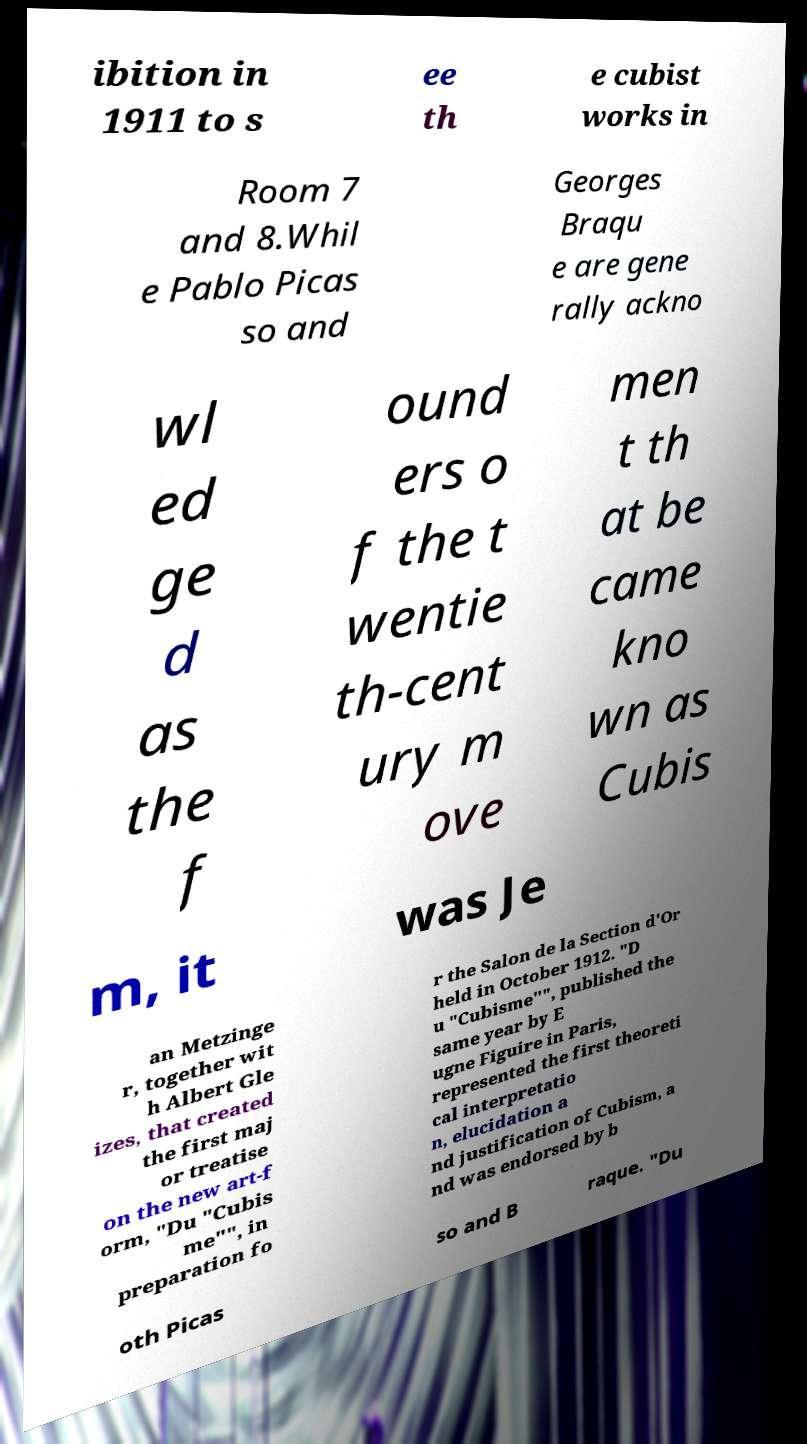I need the written content from this picture converted into text. Can you do that? ibition in 1911 to s ee th e cubist works in Room 7 and 8.Whil e Pablo Picas so and Georges Braqu e are gene rally ackno wl ed ge d as the f ound ers o f the t wentie th-cent ury m ove men t th at be came kno wn as Cubis m, it was Je an Metzinge r, together wit h Albert Gle izes, that created the first maj or treatise on the new art-f orm, "Du "Cubis me"", in preparation fo r the Salon de la Section d'Or held in October 1912. "D u "Cubisme"", published the same year by E ugne Figuire in Paris, represented the first theoreti cal interpretatio n, elucidation a nd justification of Cubism, a nd was endorsed by b oth Picas so and B raque. "Du 